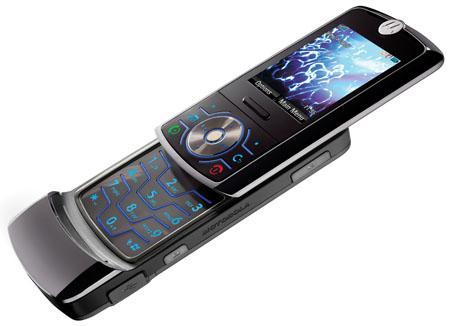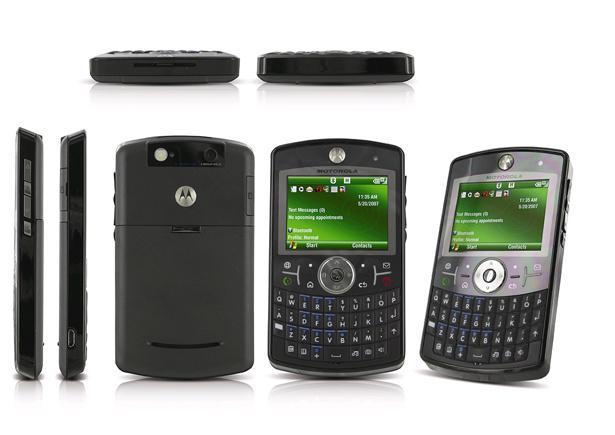The first image is the image on the left, the second image is the image on the right. For the images shown, is this caption "There are at least three phones side by side in one of the pictures." true? Answer yes or no. Yes. The first image is the image on the left, the second image is the image on the right. Given the left and right images, does the statement "The left image contains one diagonally-displayed black phone with a picture on its screen and its front slid partly up to reveal its keypad." hold true? Answer yes or no. Yes. 